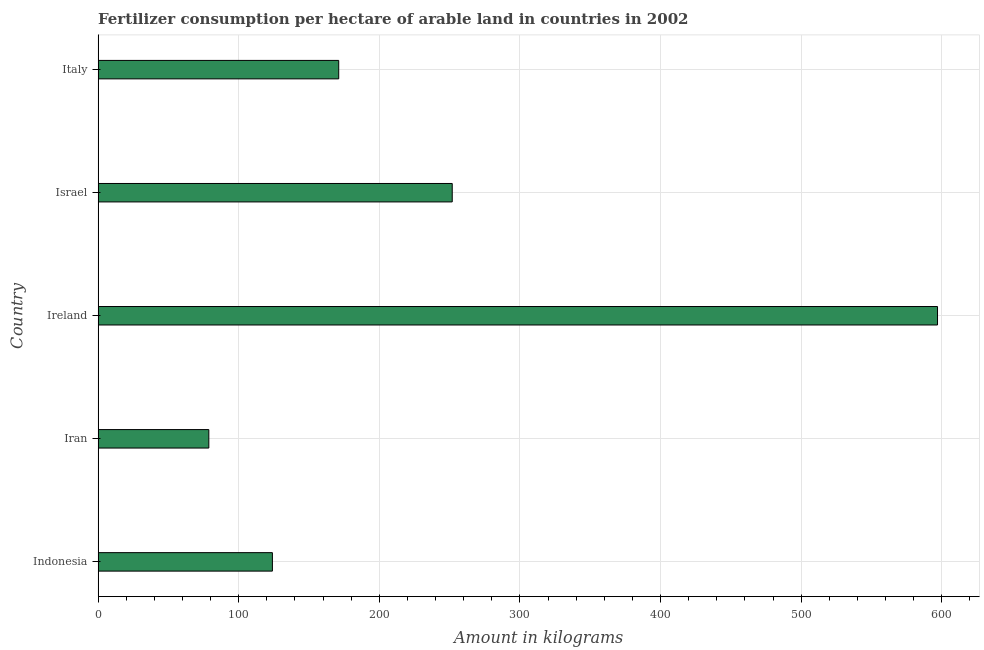Does the graph contain any zero values?
Keep it short and to the point. No. Does the graph contain grids?
Your response must be concise. Yes. What is the title of the graph?
Your answer should be compact. Fertilizer consumption per hectare of arable land in countries in 2002 . What is the label or title of the X-axis?
Make the answer very short. Amount in kilograms. What is the label or title of the Y-axis?
Provide a short and direct response. Country. What is the amount of fertilizer consumption in Ireland?
Give a very brief answer. 597.02. Across all countries, what is the maximum amount of fertilizer consumption?
Give a very brief answer. 597.02. Across all countries, what is the minimum amount of fertilizer consumption?
Provide a short and direct response. 78.74. In which country was the amount of fertilizer consumption maximum?
Your answer should be compact. Ireland. In which country was the amount of fertilizer consumption minimum?
Provide a short and direct response. Iran. What is the sum of the amount of fertilizer consumption?
Your response must be concise. 1222.7. What is the difference between the amount of fertilizer consumption in Iran and Ireland?
Provide a succinct answer. -518.28. What is the average amount of fertilizer consumption per country?
Your response must be concise. 244.54. What is the median amount of fertilizer consumption?
Offer a very short reply. 171.12. In how many countries, is the amount of fertilizer consumption greater than 520 kg?
Provide a short and direct response. 1. What is the ratio of the amount of fertilizer consumption in Indonesia to that in Iran?
Offer a terse response. 1.57. Is the difference between the amount of fertilizer consumption in Indonesia and Israel greater than the difference between any two countries?
Offer a very short reply. No. What is the difference between the highest and the second highest amount of fertilizer consumption?
Provide a succinct answer. 345.15. Is the sum of the amount of fertilizer consumption in Indonesia and Israel greater than the maximum amount of fertilizer consumption across all countries?
Your answer should be compact. No. What is the difference between the highest and the lowest amount of fertilizer consumption?
Give a very brief answer. 518.28. Are all the bars in the graph horizontal?
Offer a terse response. Yes. How many countries are there in the graph?
Keep it short and to the point. 5. What is the difference between two consecutive major ticks on the X-axis?
Your response must be concise. 100. What is the Amount in kilograms of Indonesia?
Offer a very short reply. 123.96. What is the Amount in kilograms of Iran?
Provide a succinct answer. 78.74. What is the Amount in kilograms in Ireland?
Your answer should be very brief. 597.02. What is the Amount in kilograms in Israel?
Make the answer very short. 251.86. What is the Amount in kilograms of Italy?
Offer a terse response. 171.12. What is the difference between the Amount in kilograms in Indonesia and Iran?
Offer a terse response. 45.22. What is the difference between the Amount in kilograms in Indonesia and Ireland?
Make the answer very short. -473.06. What is the difference between the Amount in kilograms in Indonesia and Israel?
Provide a short and direct response. -127.9. What is the difference between the Amount in kilograms in Indonesia and Italy?
Your answer should be very brief. -47.16. What is the difference between the Amount in kilograms in Iran and Ireland?
Provide a succinct answer. -518.28. What is the difference between the Amount in kilograms in Iran and Israel?
Provide a succinct answer. -173.12. What is the difference between the Amount in kilograms in Iran and Italy?
Keep it short and to the point. -92.38. What is the difference between the Amount in kilograms in Ireland and Israel?
Your answer should be compact. 345.16. What is the difference between the Amount in kilograms in Ireland and Italy?
Your answer should be compact. 425.9. What is the difference between the Amount in kilograms in Israel and Italy?
Offer a very short reply. 80.74. What is the ratio of the Amount in kilograms in Indonesia to that in Iran?
Make the answer very short. 1.57. What is the ratio of the Amount in kilograms in Indonesia to that in Ireland?
Your response must be concise. 0.21. What is the ratio of the Amount in kilograms in Indonesia to that in Israel?
Offer a very short reply. 0.49. What is the ratio of the Amount in kilograms in Indonesia to that in Italy?
Give a very brief answer. 0.72. What is the ratio of the Amount in kilograms in Iran to that in Ireland?
Provide a succinct answer. 0.13. What is the ratio of the Amount in kilograms in Iran to that in Israel?
Keep it short and to the point. 0.31. What is the ratio of the Amount in kilograms in Iran to that in Italy?
Your answer should be compact. 0.46. What is the ratio of the Amount in kilograms in Ireland to that in Israel?
Offer a very short reply. 2.37. What is the ratio of the Amount in kilograms in Ireland to that in Italy?
Ensure brevity in your answer.  3.49. What is the ratio of the Amount in kilograms in Israel to that in Italy?
Give a very brief answer. 1.47. 